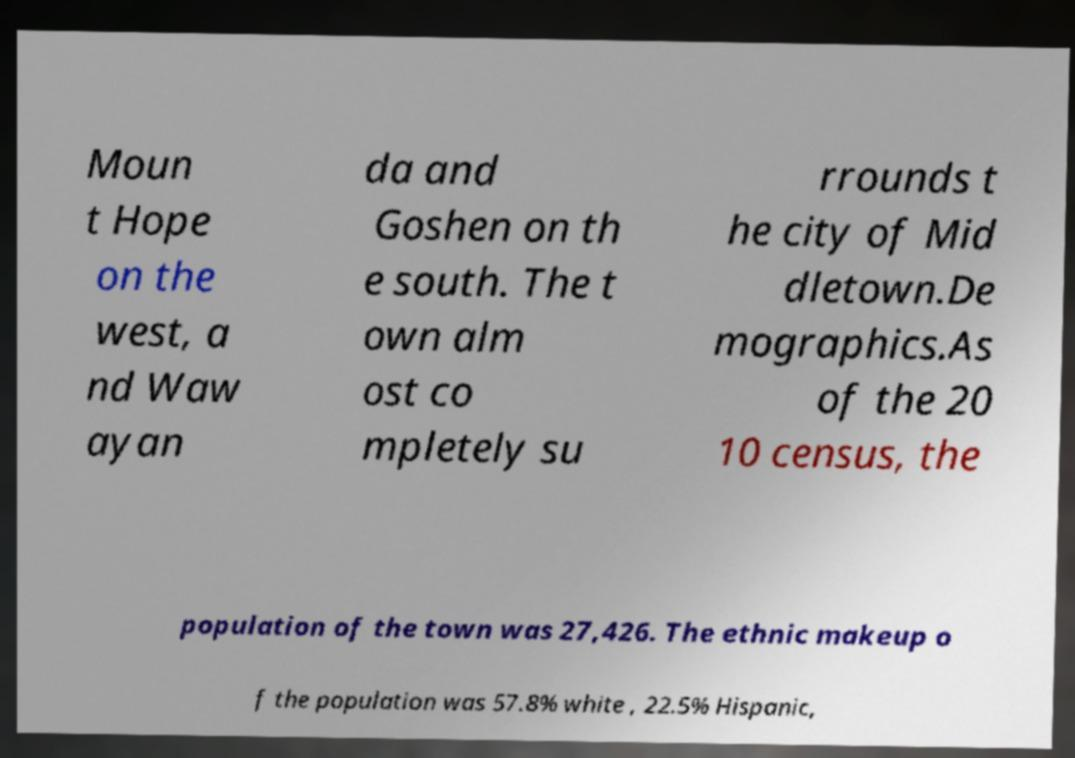Can you accurately transcribe the text from the provided image for me? Moun t Hope on the west, a nd Waw ayan da and Goshen on th e south. The t own alm ost co mpletely su rrounds t he city of Mid dletown.De mographics.As of the 20 10 census, the population of the town was 27,426. The ethnic makeup o f the population was 57.8% white , 22.5% Hispanic, 